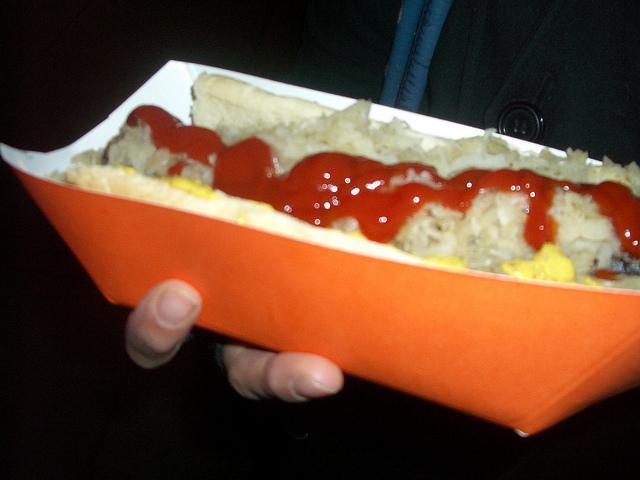Evaluate: Does the caption "The hot dog is at the right side of the person." match the image?
Answer yes or no. No. 